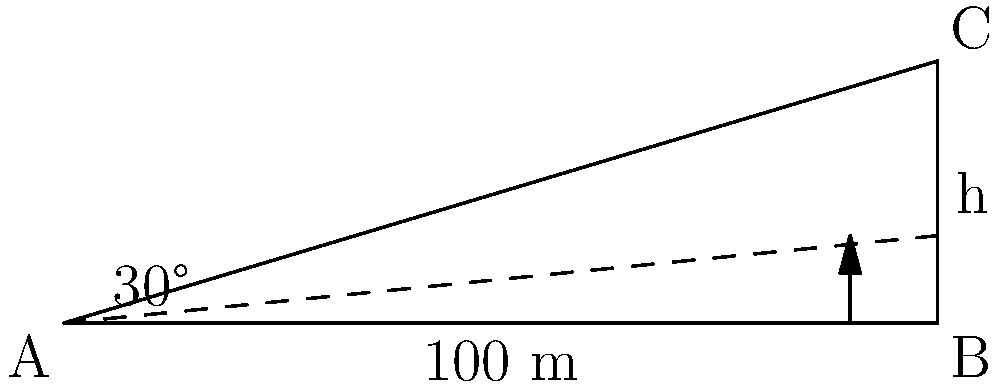You are planning a tour to a terraced tea field in Yunnan, China. The field is on a hillside with a 30° slope. If the horizontal distance from the bottom to the top of the terrace is 100 meters, what is the vertical height (h) of the terrace? Round your answer to the nearest meter. To solve this problem, we'll use trigonometry, specifically the tangent function. Here's a step-by-step explanation:

1) In a right triangle, tangent of an angle is the ratio of the opposite side to the adjacent side.

2) In this case:
   - The angle is 30°
   - The adjacent side (horizontal distance) is 100 meters
   - We need to find the opposite side (vertical height)

3) We can express this relationship as:

   $$\tan(30°) = \frac{\text{opposite}}{\text{adjacent}} = \frac{h}{100}$$

4) We know that $\tan(30°) = \frac{1}{\sqrt{3}} \approx 0.5774$

5) Substituting this value:

   $$0.5774 = \frac{h}{100}$$

6) Solving for h:

   $$h = 100 * 0.5774 = 57.74$$

7) Rounding to the nearest meter:

   $$h \approx 58 \text{ meters}$$

This height represents the vertical rise of the terraced tea field over a 100-meter horizontal distance, giving you an idea of the steepness of the hillside where the tea is grown.
Answer: 58 meters 